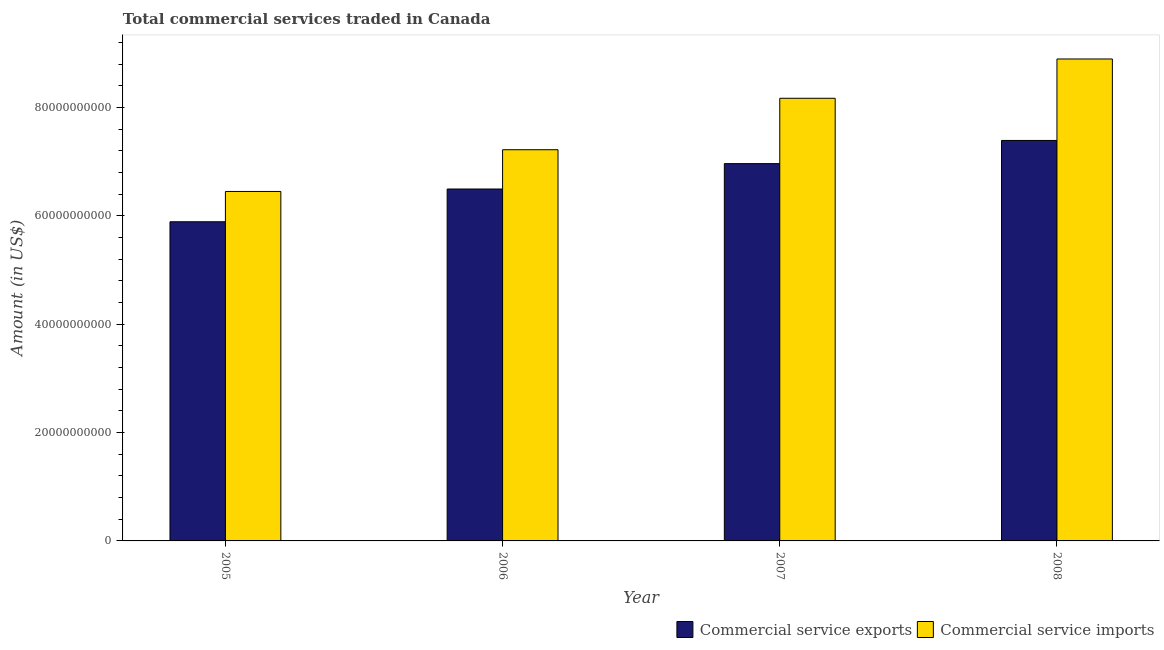Are the number of bars on each tick of the X-axis equal?
Provide a short and direct response. Yes. What is the label of the 3rd group of bars from the left?
Make the answer very short. 2007. What is the amount of commercial service imports in 2006?
Keep it short and to the point. 7.22e+1. Across all years, what is the maximum amount of commercial service imports?
Provide a succinct answer. 8.90e+1. Across all years, what is the minimum amount of commercial service exports?
Provide a short and direct response. 5.89e+1. What is the total amount of commercial service exports in the graph?
Offer a terse response. 2.67e+11. What is the difference between the amount of commercial service exports in 2005 and that in 2007?
Offer a terse response. -1.07e+1. What is the difference between the amount of commercial service exports in 2006 and the amount of commercial service imports in 2008?
Keep it short and to the point. -8.96e+09. What is the average amount of commercial service imports per year?
Your response must be concise. 7.68e+1. In how many years, is the amount of commercial service imports greater than 88000000000 US$?
Make the answer very short. 1. What is the ratio of the amount of commercial service imports in 2007 to that in 2008?
Provide a short and direct response. 0.92. Is the difference between the amount of commercial service imports in 2006 and 2007 greater than the difference between the amount of commercial service exports in 2006 and 2007?
Your answer should be very brief. No. What is the difference between the highest and the second highest amount of commercial service imports?
Make the answer very short. 7.25e+09. What is the difference between the highest and the lowest amount of commercial service imports?
Make the answer very short. 2.45e+1. What does the 1st bar from the left in 2005 represents?
Provide a short and direct response. Commercial service exports. What does the 1st bar from the right in 2006 represents?
Offer a terse response. Commercial service imports. How many bars are there?
Give a very brief answer. 8. Does the graph contain grids?
Your answer should be very brief. No. Where does the legend appear in the graph?
Ensure brevity in your answer.  Bottom right. How are the legend labels stacked?
Make the answer very short. Horizontal. What is the title of the graph?
Provide a succinct answer. Total commercial services traded in Canada. Does "Nonresident" appear as one of the legend labels in the graph?
Provide a succinct answer. No. What is the label or title of the X-axis?
Your response must be concise. Year. What is the label or title of the Y-axis?
Your answer should be very brief. Amount (in US$). What is the Amount (in US$) of Commercial service exports in 2005?
Ensure brevity in your answer.  5.89e+1. What is the Amount (in US$) of Commercial service imports in 2005?
Your answer should be compact. 6.45e+1. What is the Amount (in US$) of Commercial service exports in 2006?
Keep it short and to the point. 6.50e+1. What is the Amount (in US$) in Commercial service imports in 2006?
Provide a short and direct response. 7.22e+1. What is the Amount (in US$) in Commercial service exports in 2007?
Make the answer very short. 6.96e+1. What is the Amount (in US$) in Commercial service imports in 2007?
Make the answer very short. 8.17e+1. What is the Amount (in US$) in Commercial service exports in 2008?
Make the answer very short. 7.39e+1. What is the Amount (in US$) in Commercial service imports in 2008?
Ensure brevity in your answer.  8.90e+1. Across all years, what is the maximum Amount (in US$) in Commercial service exports?
Your answer should be compact. 7.39e+1. Across all years, what is the maximum Amount (in US$) in Commercial service imports?
Provide a succinct answer. 8.90e+1. Across all years, what is the minimum Amount (in US$) in Commercial service exports?
Your answer should be very brief. 5.89e+1. Across all years, what is the minimum Amount (in US$) of Commercial service imports?
Provide a short and direct response. 6.45e+1. What is the total Amount (in US$) of Commercial service exports in the graph?
Your answer should be compact. 2.67e+11. What is the total Amount (in US$) in Commercial service imports in the graph?
Give a very brief answer. 3.07e+11. What is the difference between the Amount (in US$) in Commercial service exports in 2005 and that in 2006?
Give a very brief answer. -6.05e+09. What is the difference between the Amount (in US$) of Commercial service imports in 2005 and that in 2006?
Offer a very short reply. -7.70e+09. What is the difference between the Amount (in US$) of Commercial service exports in 2005 and that in 2007?
Offer a very short reply. -1.07e+1. What is the difference between the Amount (in US$) in Commercial service imports in 2005 and that in 2007?
Make the answer very short. -1.72e+1. What is the difference between the Amount (in US$) in Commercial service exports in 2005 and that in 2008?
Offer a terse response. -1.50e+1. What is the difference between the Amount (in US$) in Commercial service imports in 2005 and that in 2008?
Make the answer very short. -2.45e+1. What is the difference between the Amount (in US$) of Commercial service exports in 2006 and that in 2007?
Your answer should be compact. -4.69e+09. What is the difference between the Amount (in US$) of Commercial service imports in 2006 and that in 2007?
Provide a succinct answer. -9.50e+09. What is the difference between the Amount (in US$) in Commercial service exports in 2006 and that in 2008?
Your response must be concise. -8.96e+09. What is the difference between the Amount (in US$) in Commercial service imports in 2006 and that in 2008?
Provide a short and direct response. -1.67e+1. What is the difference between the Amount (in US$) in Commercial service exports in 2007 and that in 2008?
Give a very brief answer. -4.28e+09. What is the difference between the Amount (in US$) in Commercial service imports in 2007 and that in 2008?
Your response must be concise. -7.25e+09. What is the difference between the Amount (in US$) in Commercial service exports in 2005 and the Amount (in US$) in Commercial service imports in 2006?
Provide a short and direct response. -1.33e+1. What is the difference between the Amount (in US$) of Commercial service exports in 2005 and the Amount (in US$) of Commercial service imports in 2007?
Your answer should be very brief. -2.28e+1. What is the difference between the Amount (in US$) in Commercial service exports in 2005 and the Amount (in US$) in Commercial service imports in 2008?
Your answer should be very brief. -3.00e+1. What is the difference between the Amount (in US$) in Commercial service exports in 2006 and the Amount (in US$) in Commercial service imports in 2007?
Keep it short and to the point. -1.67e+1. What is the difference between the Amount (in US$) of Commercial service exports in 2006 and the Amount (in US$) of Commercial service imports in 2008?
Provide a succinct answer. -2.40e+1. What is the difference between the Amount (in US$) in Commercial service exports in 2007 and the Amount (in US$) in Commercial service imports in 2008?
Your answer should be very brief. -1.93e+1. What is the average Amount (in US$) of Commercial service exports per year?
Provide a succinct answer. 6.69e+1. What is the average Amount (in US$) of Commercial service imports per year?
Give a very brief answer. 7.68e+1. In the year 2005, what is the difference between the Amount (in US$) in Commercial service exports and Amount (in US$) in Commercial service imports?
Your answer should be very brief. -5.59e+09. In the year 2006, what is the difference between the Amount (in US$) in Commercial service exports and Amount (in US$) in Commercial service imports?
Your answer should be very brief. -7.25e+09. In the year 2007, what is the difference between the Amount (in US$) in Commercial service exports and Amount (in US$) in Commercial service imports?
Provide a succinct answer. -1.21e+1. In the year 2008, what is the difference between the Amount (in US$) in Commercial service exports and Amount (in US$) in Commercial service imports?
Offer a very short reply. -1.50e+1. What is the ratio of the Amount (in US$) of Commercial service exports in 2005 to that in 2006?
Give a very brief answer. 0.91. What is the ratio of the Amount (in US$) in Commercial service imports in 2005 to that in 2006?
Your answer should be compact. 0.89. What is the ratio of the Amount (in US$) in Commercial service exports in 2005 to that in 2007?
Your answer should be very brief. 0.85. What is the ratio of the Amount (in US$) of Commercial service imports in 2005 to that in 2007?
Your answer should be very brief. 0.79. What is the ratio of the Amount (in US$) in Commercial service exports in 2005 to that in 2008?
Ensure brevity in your answer.  0.8. What is the ratio of the Amount (in US$) of Commercial service imports in 2005 to that in 2008?
Your answer should be compact. 0.73. What is the ratio of the Amount (in US$) of Commercial service exports in 2006 to that in 2007?
Offer a very short reply. 0.93. What is the ratio of the Amount (in US$) of Commercial service imports in 2006 to that in 2007?
Make the answer very short. 0.88. What is the ratio of the Amount (in US$) of Commercial service exports in 2006 to that in 2008?
Provide a succinct answer. 0.88. What is the ratio of the Amount (in US$) in Commercial service imports in 2006 to that in 2008?
Keep it short and to the point. 0.81. What is the ratio of the Amount (in US$) of Commercial service exports in 2007 to that in 2008?
Keep it short and to the point. 0.94. What is the ratio of the Amount (in US$) of Commercial service imports in 2007 to that in 2008?
Offer a terse response. 0.92. What is the difference between the highest and the second highest Amount (in US$) of Commercial service exports?
Provide a short and direct response. 4.28e+09. What is the difference between the highest and the second highest Amount (in US$) in Commercial service imports?
Your response must be concise. 7.25e+09. What is the difference between the highest and the lowest Amount (in US$) in Commercial service exports?
Make the answer very short. 1.50e+1. What is the difference between the highest and the lowest Amount (in US$) in Commercial service imports?
Ensure brevity in your answer.  2.45e+1. 